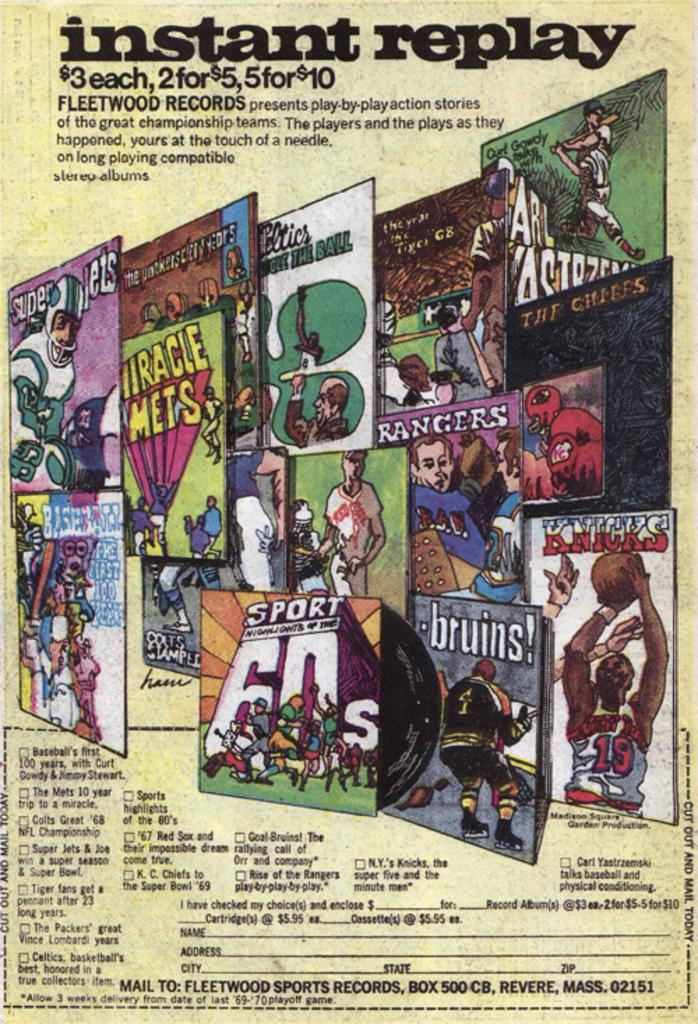<image>
Provide a brief description of the given image. Poster for instant replay with many posters inside 